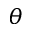Convert formula to latex. <formula><loc_0><loc_0><loc_500><loc_500>\theta</formula> 